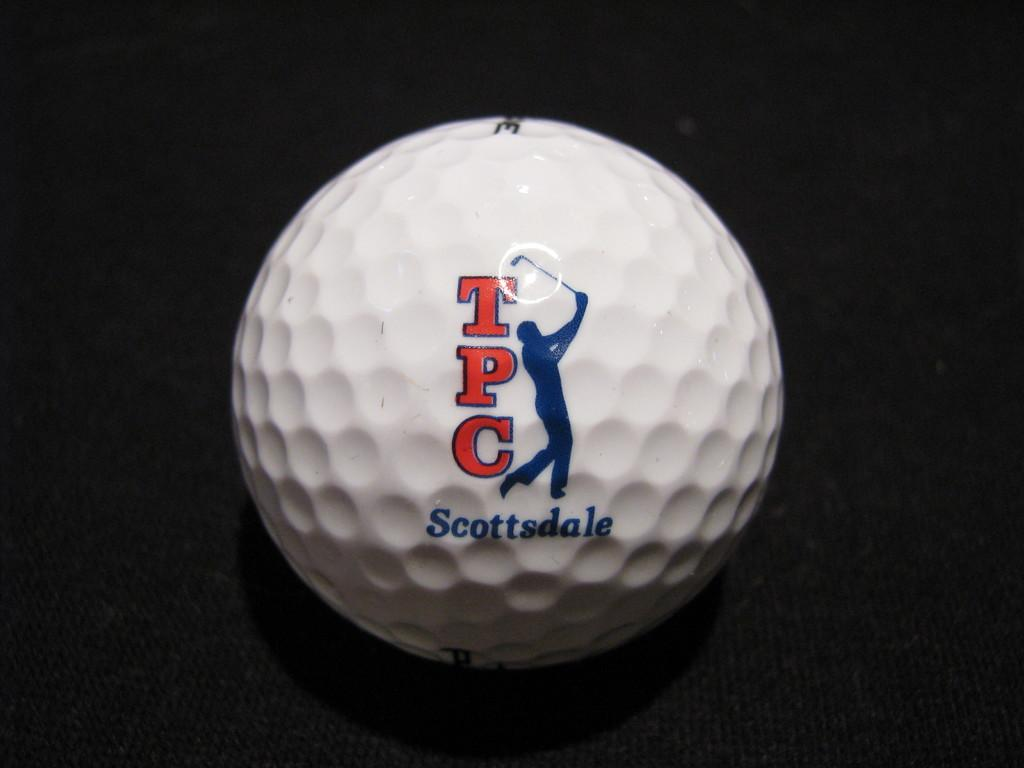<image>
Write a terse but informative summary of the picture. A white golf ball that says TPC Scottsdale. 